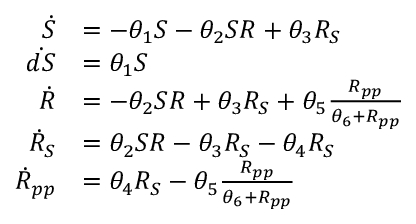<formula> <loc_0><loc_0><loc_500><loc_500>\begin{array} { r l } { \dot { S } } & { = - \theta _ { 1 } S - \theta _ { 2 } S R + \theta _ { 3 } R _ { S } } \\ { \dot { d S } } & { = \theta _ { 1 } S } \\ { \dot { R } } & { = - \theta _ { 2 } S R + \theta _ { 3 } R _ { S } + \theta _ { 5 } \frac { R _ { p p } } { \theta _ { 6 } + R _ { p p } } } \\ { \dot { R } _ { S } } & { = \theta _ { 2 } S R - \theta _ { 3 } R _ { S } - \theta _ { 4 } R _ { S } } \\ { \dot { R } _ { p p } } & { = \theta _ { 4 } R _ { S } - \theta _ { 5 } \frac { R _ { p p } } { \theta _ { 6 } + R _ { p p } } } \end{array}</formula> 